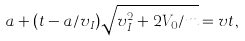Convert formula to latex. <formula><loc_0><loc_0><loc_500><loc_500>a + ( t - a / v _ { I } ) \sqrt { v _ { I } ^ { 2 } + 2 V _ { 0 } / m } = v t ,</formula> 